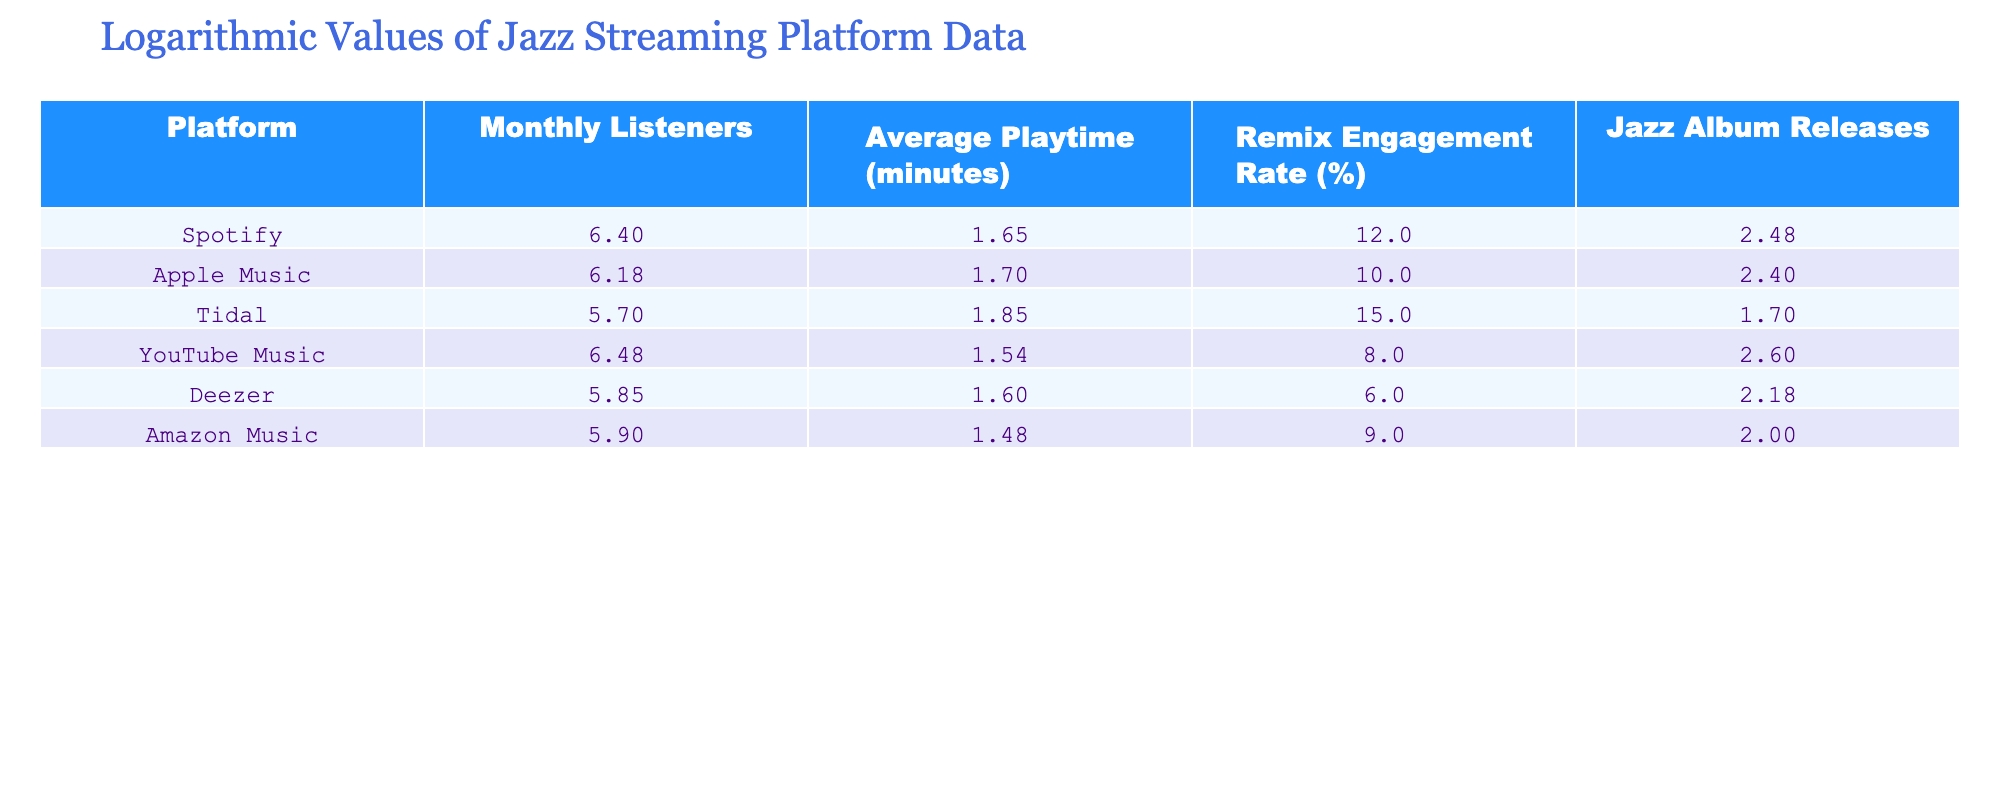What is the platform with the highest monthly listeners? Looking at the 'Monthly Listeners' column, the values indicate that Spotify has the highest number of monthly listeners at 2,500,000.
Answer: Spotify What is the average playtime on Tidal? The table shows that Tidal has an 'Average Playtime' of 70 minutes.
Answer: 70 minutes What is the engagement rate for YouTube Music? According to the table, YouTube Music has a 'Remix Engagement Rate' of 8%.
Answer: 8% Is the engagement rate for Deezer greater than that of Apple Music? By comparing the 'Remix Engagement Rate' columns, Deezer has a rate of 6%, which is less than Apple Music's rate of 10%. Therefore, the statement is false.
Answer: No What is the average number of jazz album releases across all platforms? First, we sum the 'Jazz Album Releases': 300 + 250 + 50 + 400 + 150 + 100 = 1250. Next, we divide by the total number of platforms (6) which gives us an average of 1250 / 6 = 208.33.
Answer: 208.33 What is the total number of monthly listeners for all platforms combined? Summing the 'Monthly Listeners' gives: 2,500,000 + 1,500,000 + 500,000 + 3,000,000 + 700,000 + 800,000 = 9,000,000.
Answer: 9,000,000 Which platform has the lowest average playtime? The 'Average Playtime' column shows that Amazon Music has the lowest value at 30 minutes when compared with other platforms.
Answer: Amazon Music Does Tidal have the highest remix engagement rate? Tidal's engagement rate is 15%, which is the highest compared to the other platforms listed. Therefore, the statement is true.
Answer: Yes What is the difference in monthly listeners between Spotify and Deezer? The monthly listeners for Spotify is 2,500,000 and for Deezer is 700,000. The difference is 2,500,000 - 700,000 = 1,800,000.
Answer: 1,800,000 